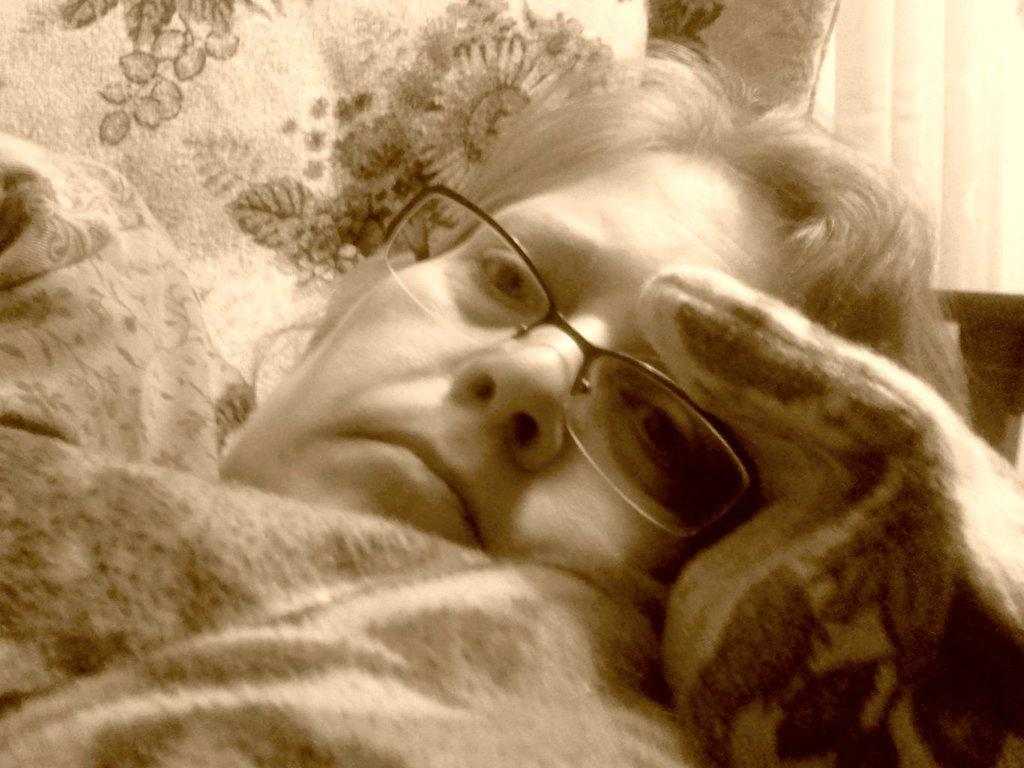What is the person in the image wearing on their face? The person is wearing spectacles. What type of string is being used to hold the books together in the image? There are no books or string present in the image; it only features a person wearing spectacles. 